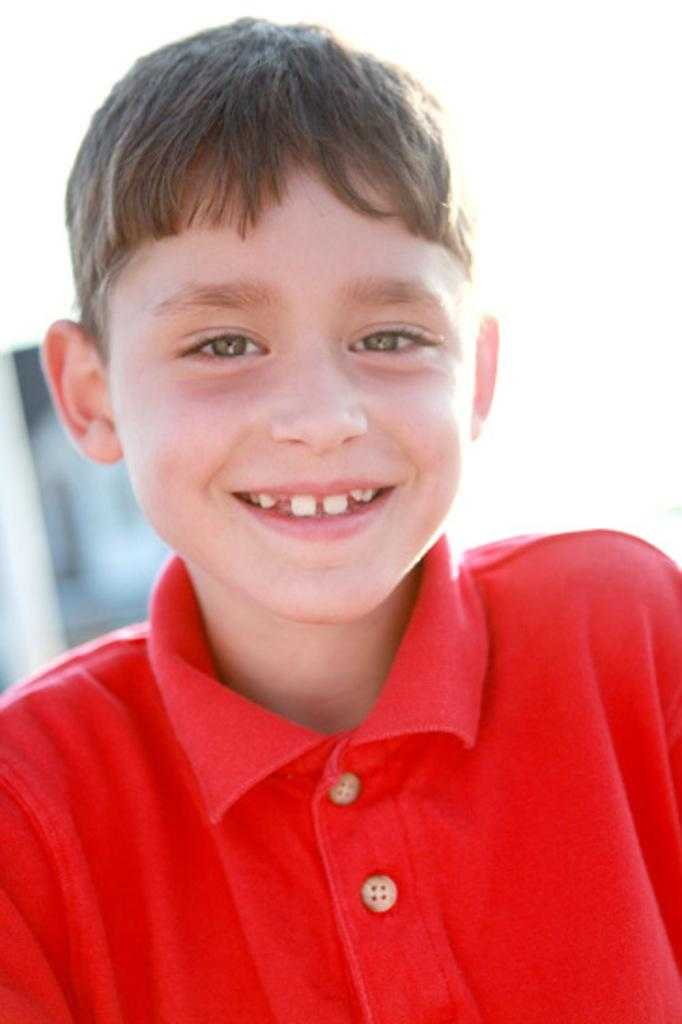Who is the main subject in the image? There is a boy in the image. What is the boy wearing? The boy is wearing a t-shirt. What type of match is the boy playing with in the image? There is no match present in the image; the boy is simply wearing a t-shirt. 